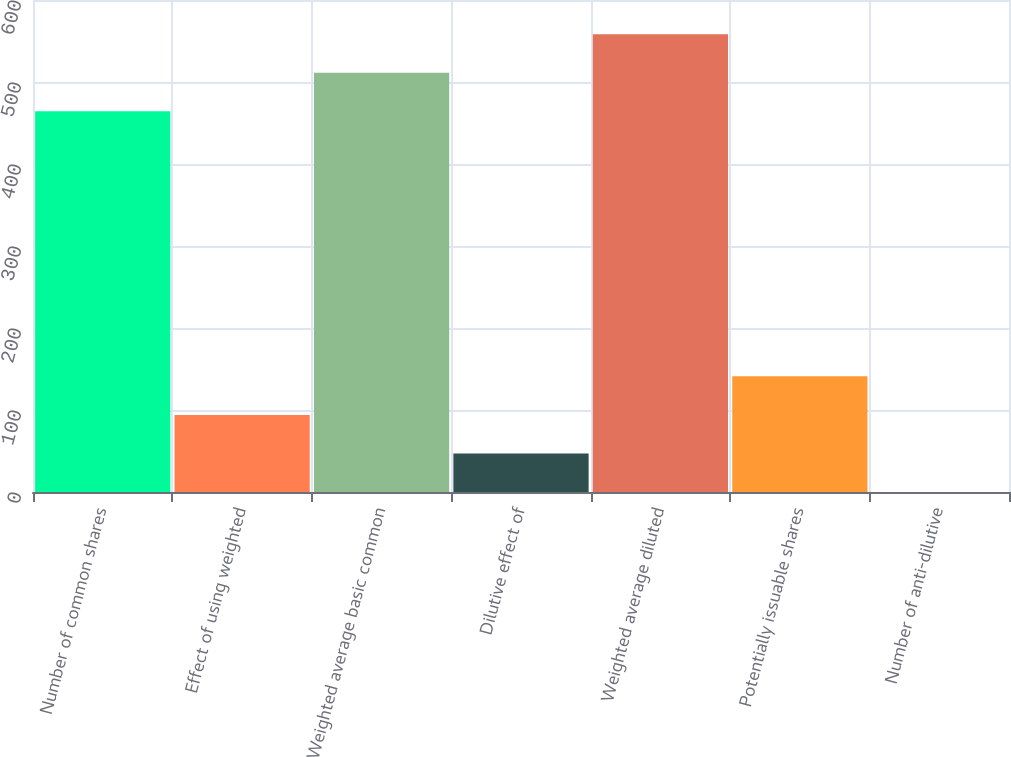<chart> <loc_0><loc_0><loc_500><loc_500><bar_chart><fcel>Number of common shares<fcel>Effect of using weighted<fcel>Weighted average basic common<fcel>Dilutive effect of<fcel>Weighted average diluted<fcel>Potentially issuable shares<fcel>Number of anti-dilutive<nl><fcel>464.3<fcel>94.04<fcel>511.27<fcel>47.07<fcel>558.24<fcel>141.01<fcel>0.1<nl></chart> 